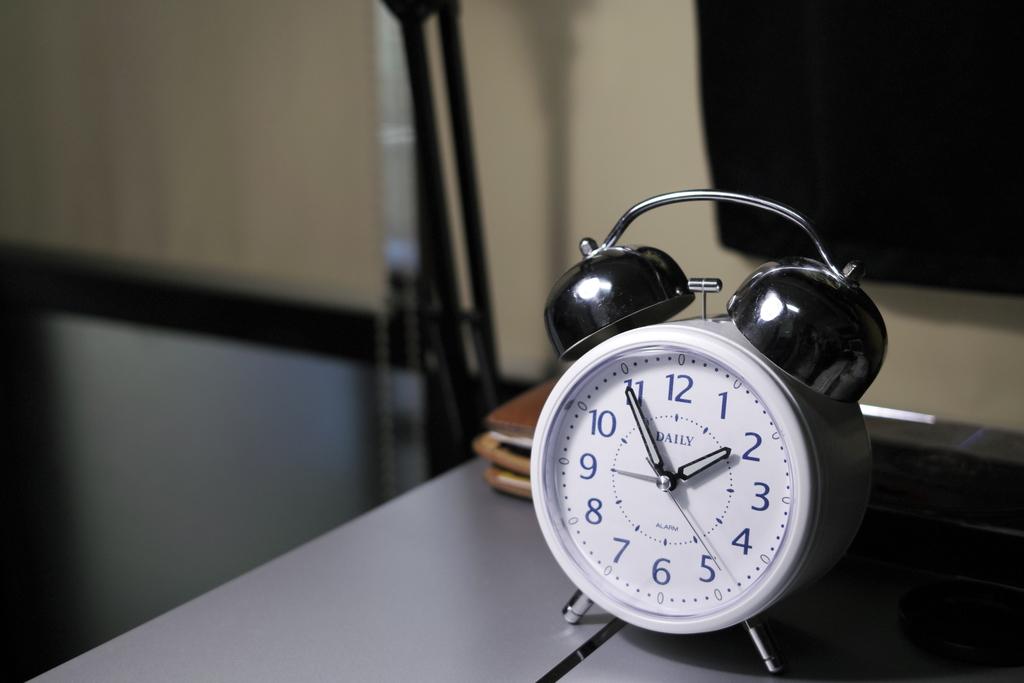What time is it?
Your answer should be compact. 1:55. What brand is the alarm clock?
Offer a terse response. Daily. 